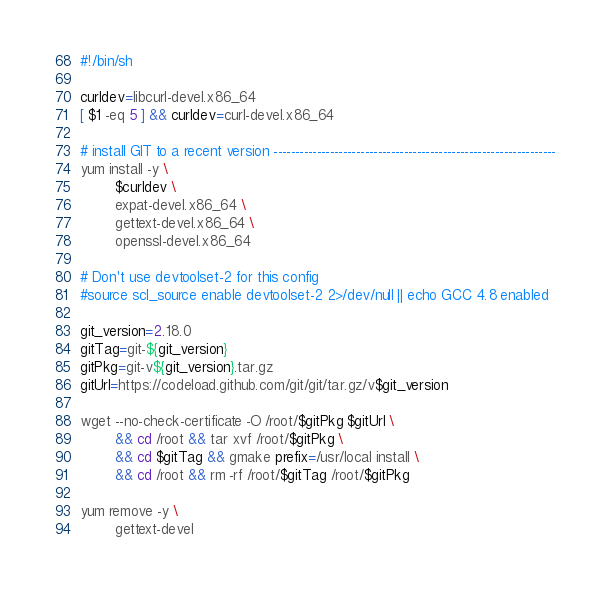Convert code to text. <code><loc_0><loc_0><loc_500><loc_500><_Bash_>#!/bin/sh

curldev=libcurl-devel.x86_64
[ $1 -eq 5 ] && curldev=curl-devel.x86_64

# install GIT to a recent version -----------------------------------------------------------------
yum install -y \
        $curldev \
        expat-devel.x86_64 \
        gettext-devel.x86_64 \
        openssl-devel.x86_64

# Don't use devtoolset-2 for this config
#source scl_source enable devtoolset-2 2>/dev/null || echo GCC 4.8 enabled

git_version=2.18.0
gitTag=git-${git_version}
gitPkg=git-v${git_version}.tar.gz
gitUrl=https://codeload.github.com/git/git/tar.gz/v$git_version

wget --no-check-certificate -O /root/$gitPkg $gitUrl \
        && cd /root && tar xvf /root/$gitPkg \
        && cd $gitTag && gmake prefix=/usr/local install \
        && cd /root && rm -rf /root/$gitTag /root/$gitPkg

yum remove -y \
        gettext-devel
</code> 